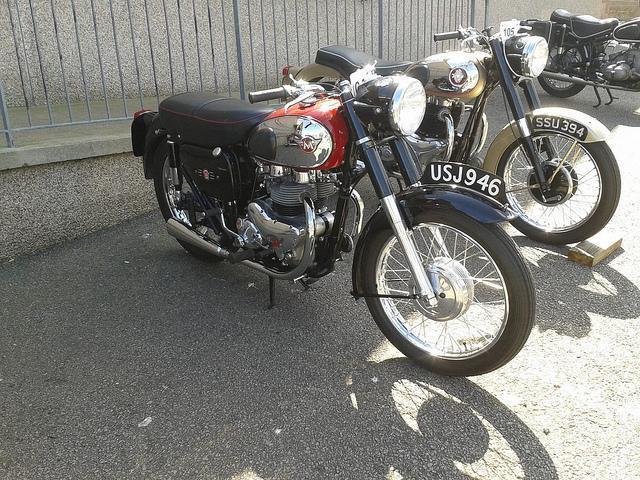How many bikes?
Give a very brief answer. 3. How many bikes are the same color?
Give a very brief answer. 2. How many motorcycles are there?
Give a very brief answer. 3. How many people are in the window?
Give a very brief answer. 0. 